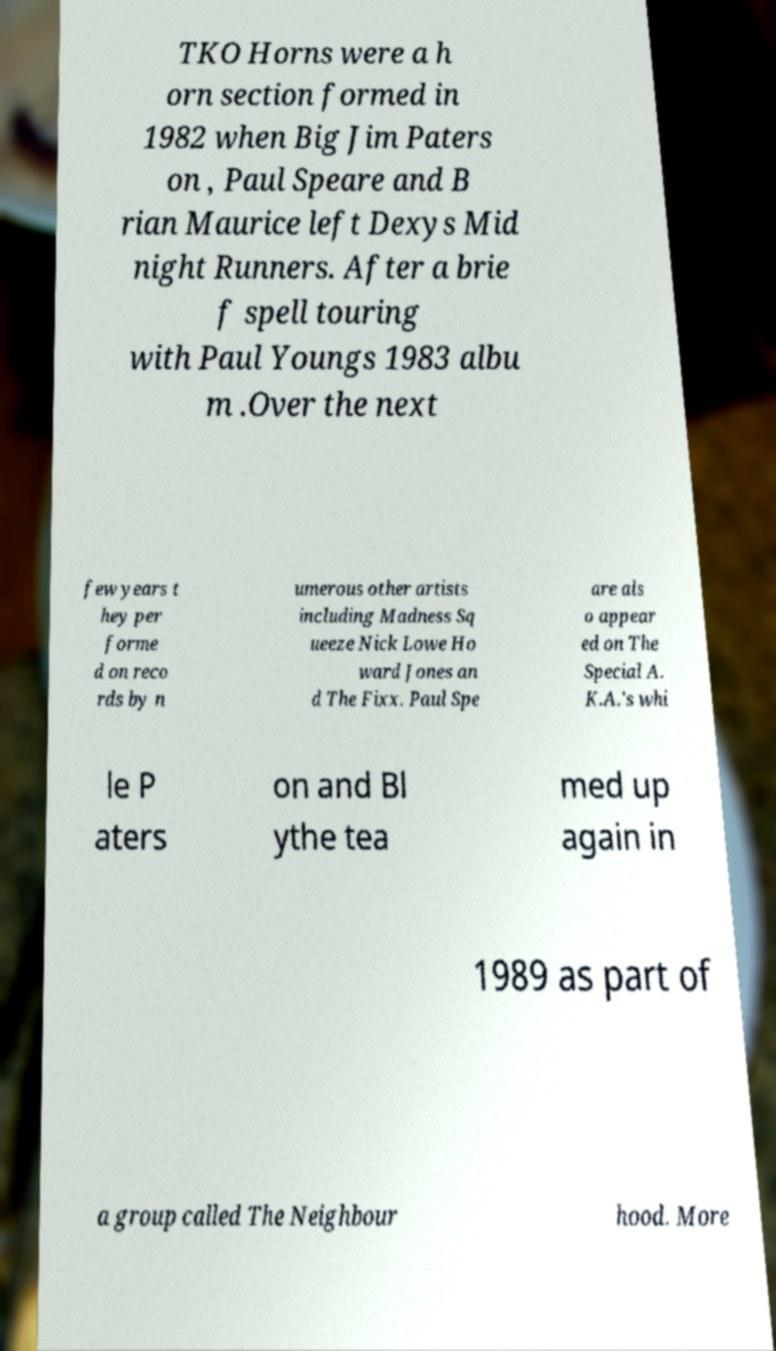There's text embedded in this image that I need extracted. Can you transcribe it verbatim? TKO Horns were a h orn section formed in 1982 when Big Jim Paters on , Paul Speare and B rian Maurice left Dexys Mid night Runners. After a brie f spell touring with Paul Youngs 1983 albu m .Over the next few years t hey per forme d on reco rds by n umerous other artists including Madness Sq ueeze Nick Lowe Ho ward Jones an d The Fixx. Paul Spe are als o appear ed on The Special A. K.A.'s whi le P aters on and Bl ythe tea med up again in 1989 as part of a group called The Neighbour hood. More 